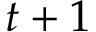Convert formula to latex. <formula><loc_0><loc_0><loc_500><loc_500>t + 1</formula> 